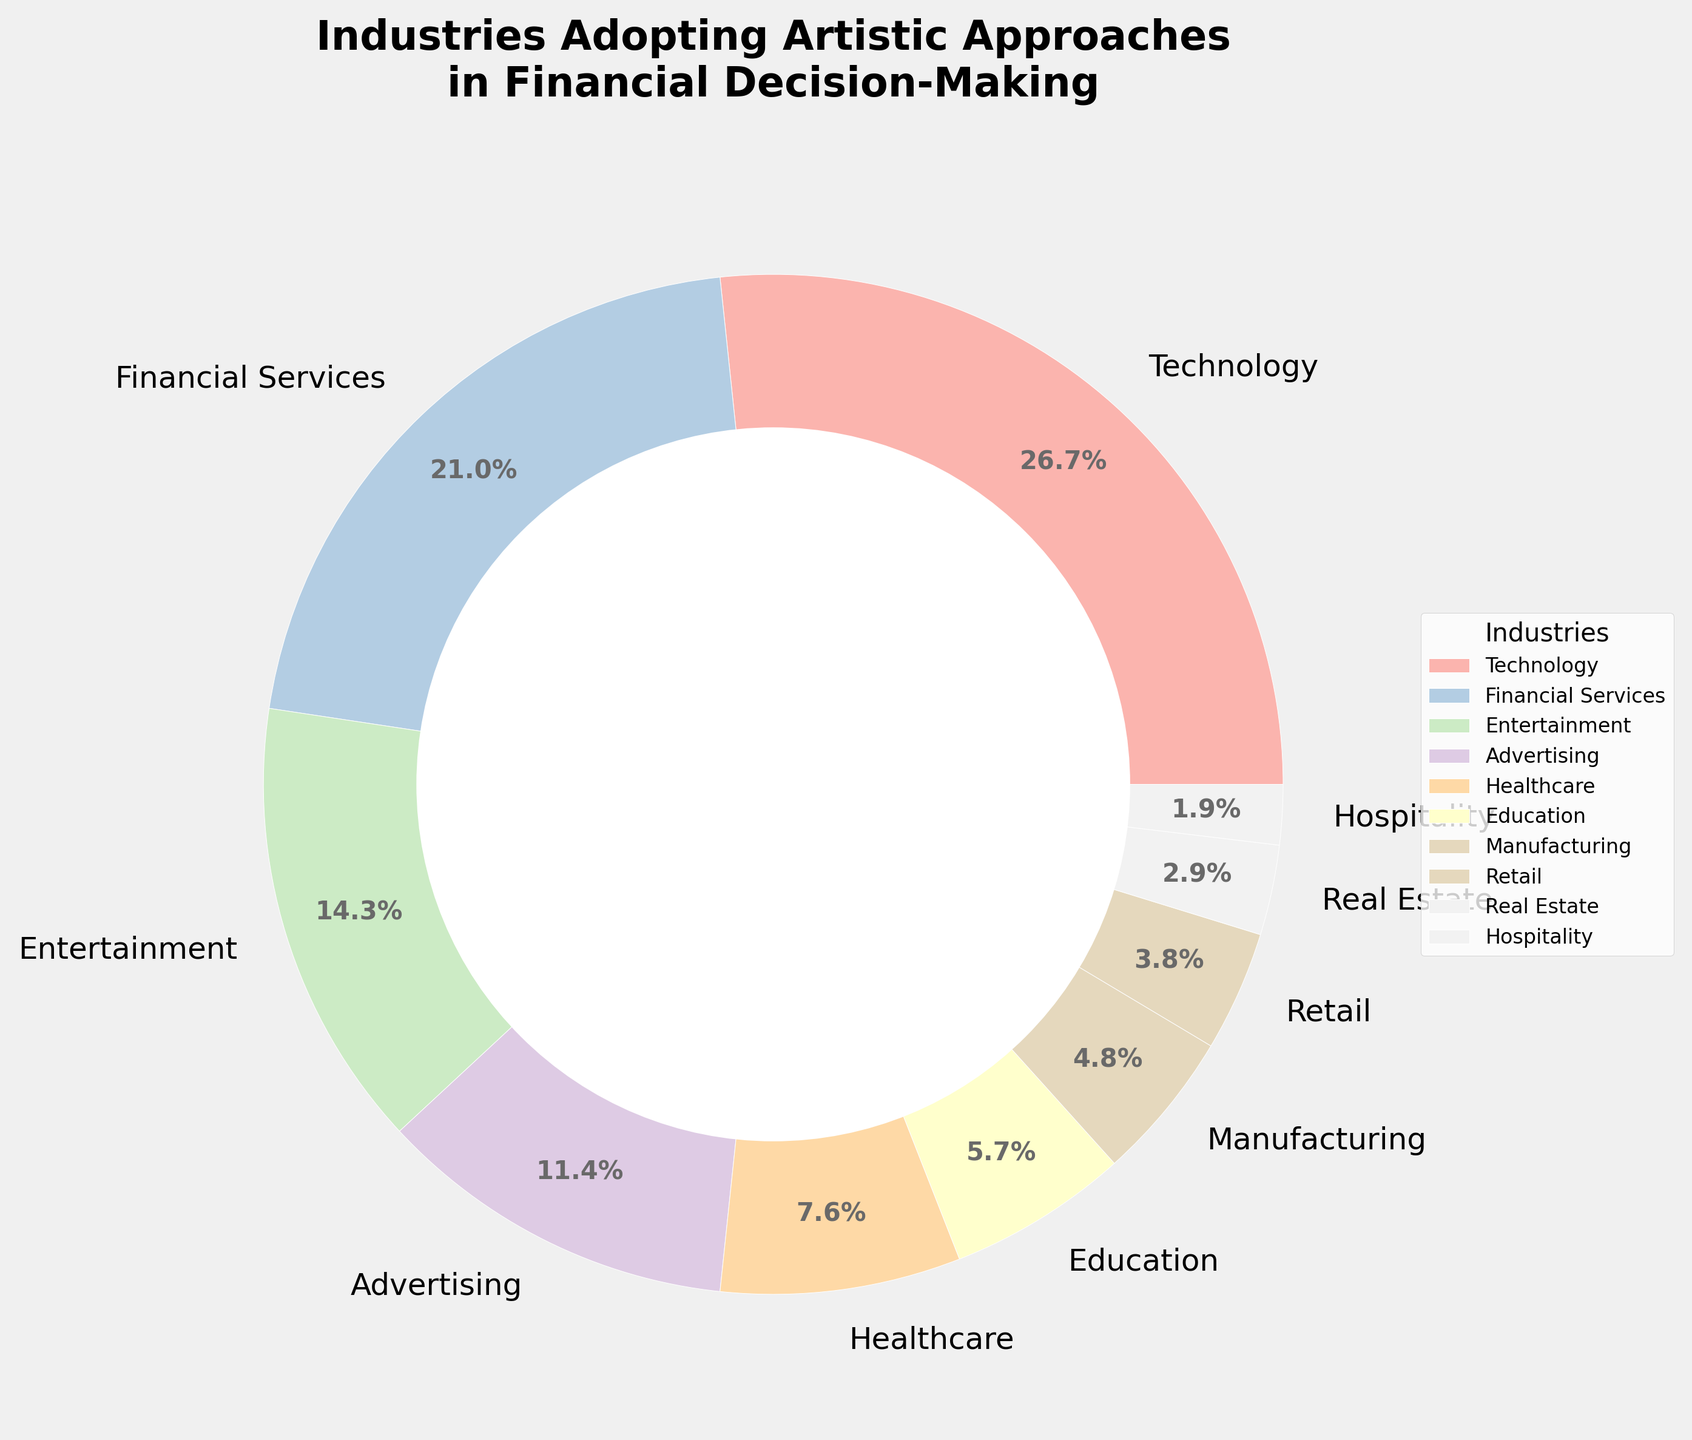What percentage of industries adopting artistic approaches in financial decision-making does the Technology sector represent? The percentage of industries for the Technology sector is clearly marked in the chart.
Answer: 28% How much higher is the percentage of the Technology sector compared to the Real Estate sector? The Technology sector is at 28%, and the Real Estate sector is at 3%. The difference is calculated as 28% - 3%.
Answer: 25% Which sector has a higher representation, Financial Services or Advertising? By observing the pie chart, Financial Services has a higher representation (22%) compared to Advertising (12%).
Answer: Financial Services What's the total percentage of industries in the Technology, Healthcare, and Education sectors combined? Adding the percentages: Technology (28%), Healthcare (8%), and Education (6%) results in 28% + 8% + 6% = 42%.
Answer: 42% Is the percentage of the Entertainment sector less than that of the Financial Services sector? From the chart, Entertainment is at 15% and Financial Services at 22%. Since 15% is less than 22%, the answer is yes.
Answer: Yes How does the percentage of the Hospitality sector compare to that of the Retail sector? The pie chart shows the Hospitality sector at 2% and the Retail sector at 4%. Hospitality has a lower percentage than Retail.
Answer: Hospitality is lower What is the average representation percentage of the Advertising and Healthcare sectors? Adding the percentages of Advertising (12%) and Healthcare (8%) and then dividing by 2: (12% + 8%) / 2 = 10%.
Answer: 10% Which sector shows the least adoption of artistic approaches, and what is its percentage? By referring to the pie chart, the Hospitality sector shows the least adoption at 2%.
Answer: Hospitality, 2% Combining the percentages of the Manufacturing and Real Estate sectors, what is the result? Adding Manufacturing (5%) and Real Estate (3%), we get 5% + 3% = 8%.
Answer: 8% What are the second and third highest sectors in terms of adopting artistic approaches? Referring to the pie chart, the second highest is Financial Services (22%) and the third highest is Entertainment (15%).
Answer: Financial Services and Entertainment 